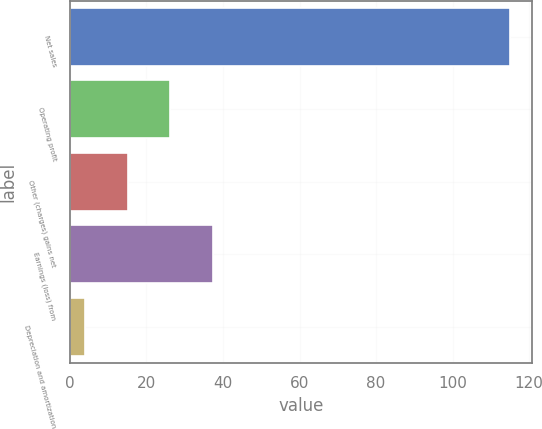Convert chart to OTSL. <chart><loc_0><loc_0><loc_500><loc_500><bar_chart><fcel>Net sales<fcel>Operating profit<fcel>Other (charges) gains net<fcel>Earnings (loss) from<fcel>Depreciation and amortization<nl><fcel>115<fcel>26.2<fcel>15.1<fcel>37.3<fcel>4<nl></chart> 